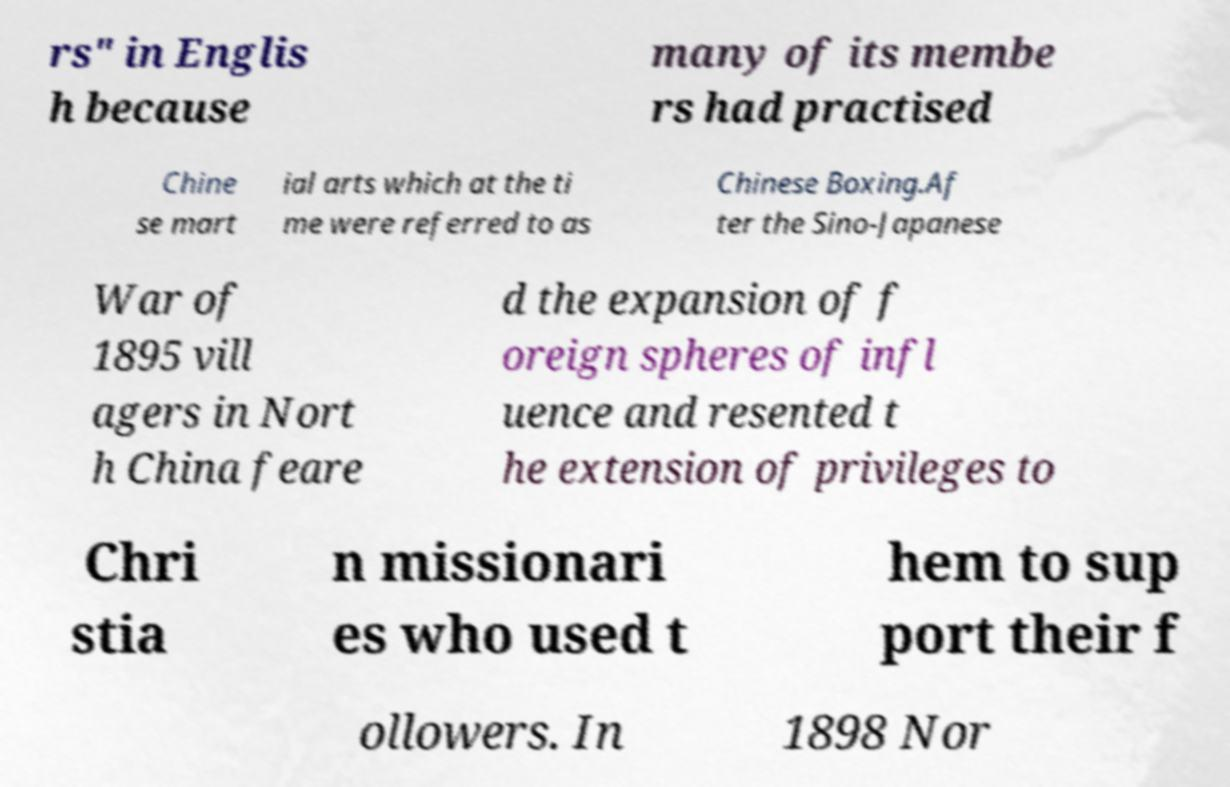Please read and relay the text visible in this image. What does it say? rs" in Englis h because many of its membe rs had practised Chine se mart ial arts which at the ti me were referred to as Chinese Boxing.Af ter the Sino-Japanese War of 1895 vill agers in Nort h China feare d the expansion of f oreign spheres of infl uence and resented t he extension of privileges to Chri stia n missionari es who used t hem to sup port their f ollowers. In 1898 Nor 